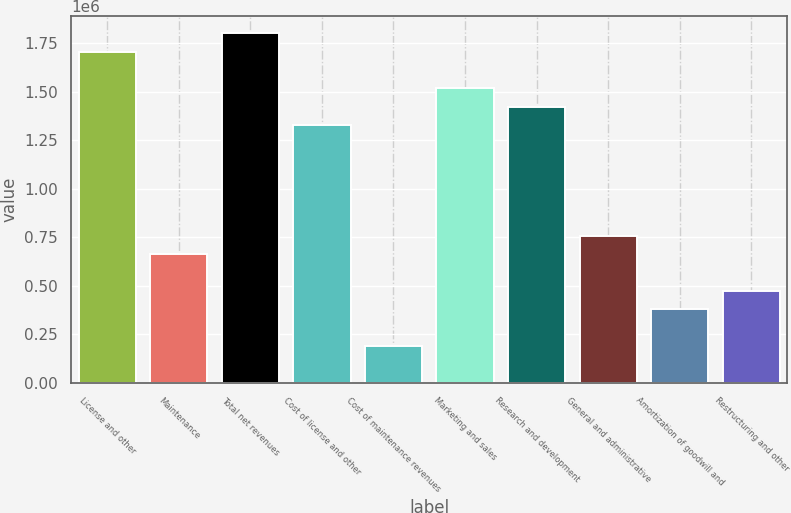Convert chart. <chart><loc_0><loc_0><loc_500><loc_500><bar_chart><fcel>License and other<fcel>Maintenance<fcel>Total net revenues<fcel>Cost of license and other<fcel>Cost of maintenance revenues<fcel>Marketing and sales<fcel>Research and development<fcel>General and administrative<fcel>Amortization of goodwill and<fcel>Restructuring and other<nl><fcel>1.70548e+06<fcel>663244<fcel>1.80023e+06<fcel>1.32649e+06<fcel>189499<fcel>1.51599e+06<fcel>1.42124e+06<fcel>757993<fcel>378997<fcel>473746<nl></chart> 